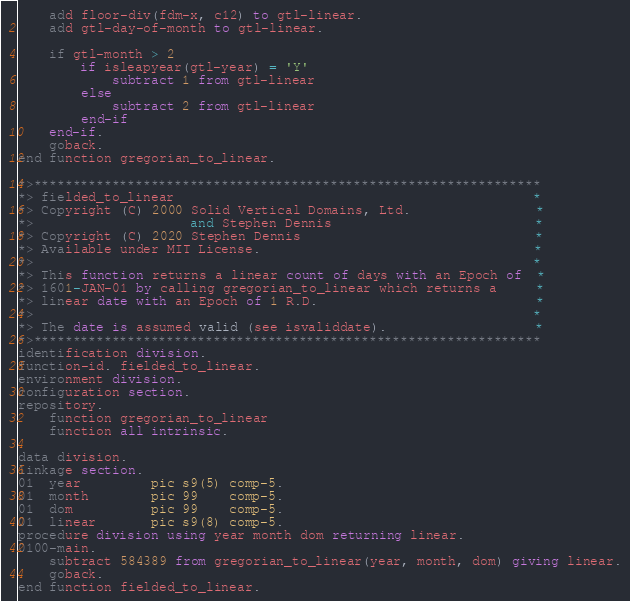<code> <loc_0><loc_0><loc_500><loc_500><_COBOL_>    add floor-div(fdm-x, c12) to gtl-linear.
    add gtl-day-of-month to gtl-linear.

    if gtl-month > 2
        if isleapyear(gtl-year) = 'Y'
            subtract 1 from gtl-linear
        else
            subtract 2 from gtl-linear
        end-if
    end-if.
    goback.
end function gregorian_to_linear.

*>*****************************************************************
*> fielded_to_linear                                              *
*> Copyright (C) 2000 Solid Vertical Domains, Ltd.                *
*>                    and Stephen Dennis                          *
*> Copyright (C) 2020 Stephen Dennis                              *
*> Available under MIT License.                                   *
*>                                                                *
*> This function returns a linear count of days with an Epoch of  *
*> 1601-JAN-01 by calling gregorian_to_linear which returns a     *
*> linear date with an Epoch of 1 R.D.                            *
*>                                                                *
*> The date is assumed valid (see isvaliddate).                   *
*>*****************************************************************
identification division.
function-id. fielded_to_linear.
environment division.
configuration section.
repository.
    function gregorian_to_linear
    function all intrinsic.

data division.
linkage section.
01  year         pic s9(5) comp-5.
01  month        pic 99    comp-5.
01  dom          pic 99    comp-5.
01  linear       pic s9(8) comp-5.
procedure division using year month dom returning linear.
0100-main.
    subtract 584389 from gregorian_to_linear(year, month, dom) giving linear.
    goback.
end function fielded_to_linear.
</code> 